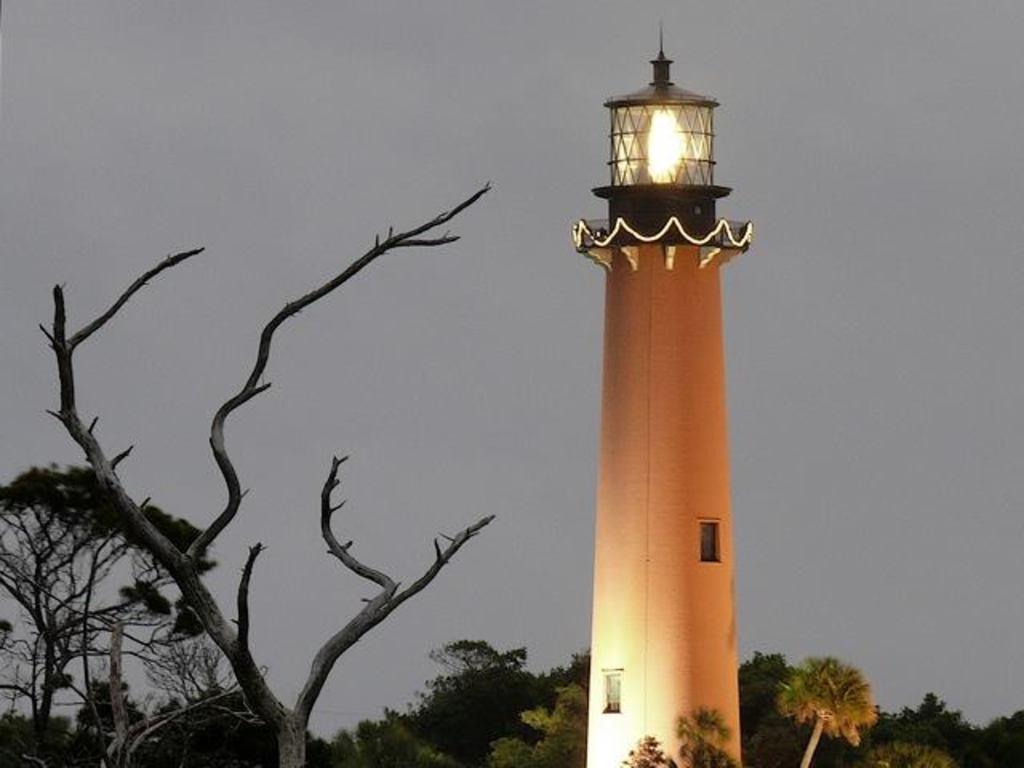Could you give a brief overview of what you see in this image? In the image there is a pillar with windows and light on the top of the pillar. On the left side of the image there is a tree without leaves. Behind them there are trees. In the background there is a sky. 